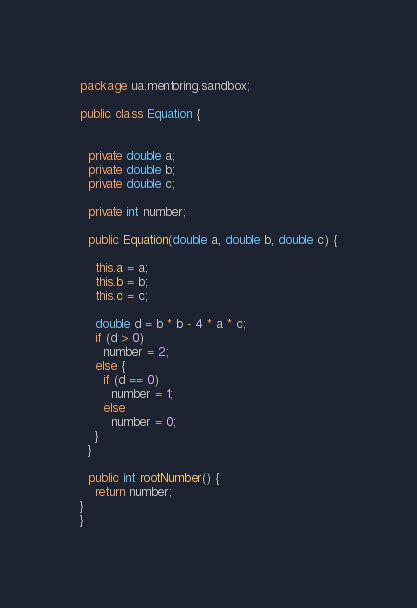Convert code to text. <code><loc_0><loc_0><loc_500><loc_500><_Java_>package ua.mentoring.sandbox;

public class Equation {


  private double a;
  private double b;
  private double c;

  private int number;

  public Equation(double a, double b, double c) {

    this.a = a;
    this.b = b;
    this.c = c;

    double d = b * b - 4 * a * c;
    if (d > 0)
      number = 2;
    else {
      if (d == 0)
        number = 1;
      else
        number = 0;
    }
  }

  public int rootNumber() {
    return number;
}
}

</code> 